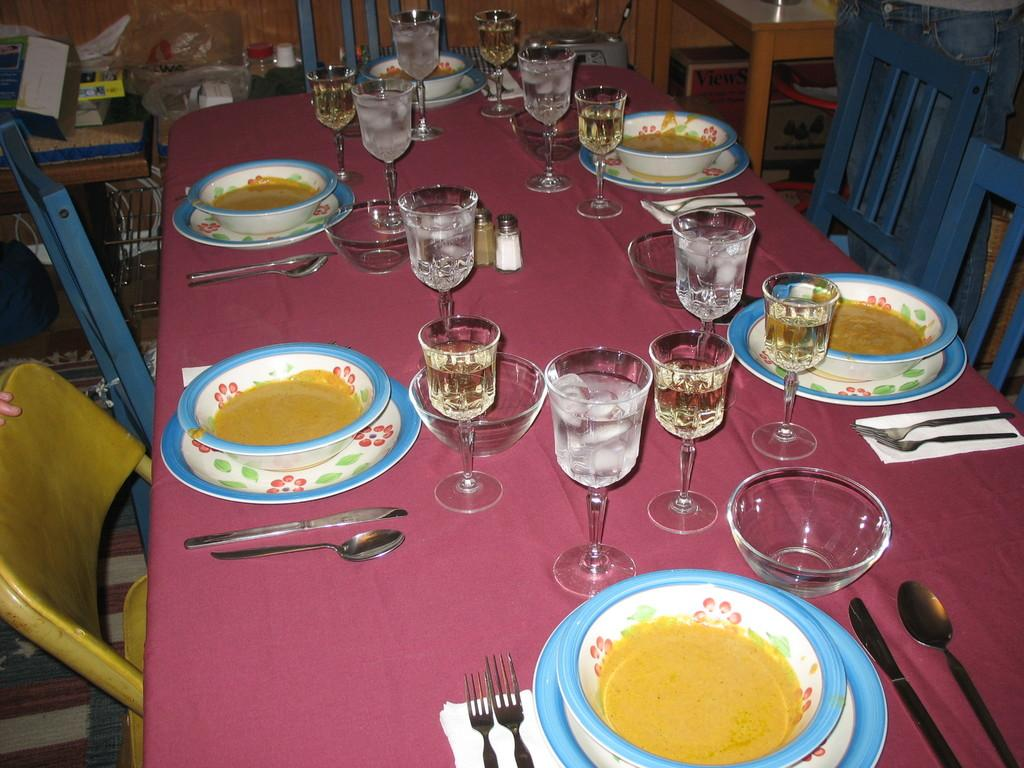What type of furniture is in the image? There is a dining table in the image. What is on the dining table? There is food in a bowl on the table. How many water glasses are on the table? There are multiple water glasses on the table. What can be seen in the background of the image? Wooden chairs are visible in the background of the image. Is there a tiger sitting at the dining table in the image? No, there is no tiger present in the image. What type of rifle is visible on the table in the image? There is no rifle present in the image; it is a dining table with food and water glasses. 